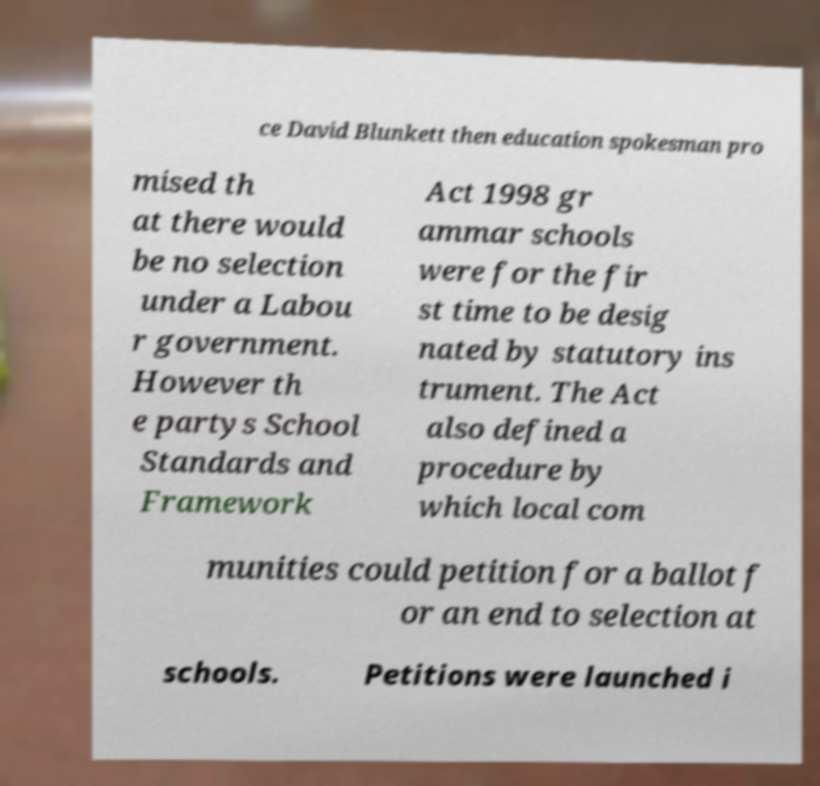What messages or text are displayed in this image? I need them in a readable, typed format. ce David Blunkett then education spokesman pro mised th at there would be no selection under a Labou r government. However th e partys School Standards and Framework Act 1998 gr ammar schools were for the fir st time to be desig nated by statutory ins trument. The Act also defined a procedure by which local com munities could petition for a ballot f or an end to selection at schools. Petitions were launched i 